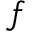<formula> <loc_0><loc_0><loc_500><loc_500>f</formula> 